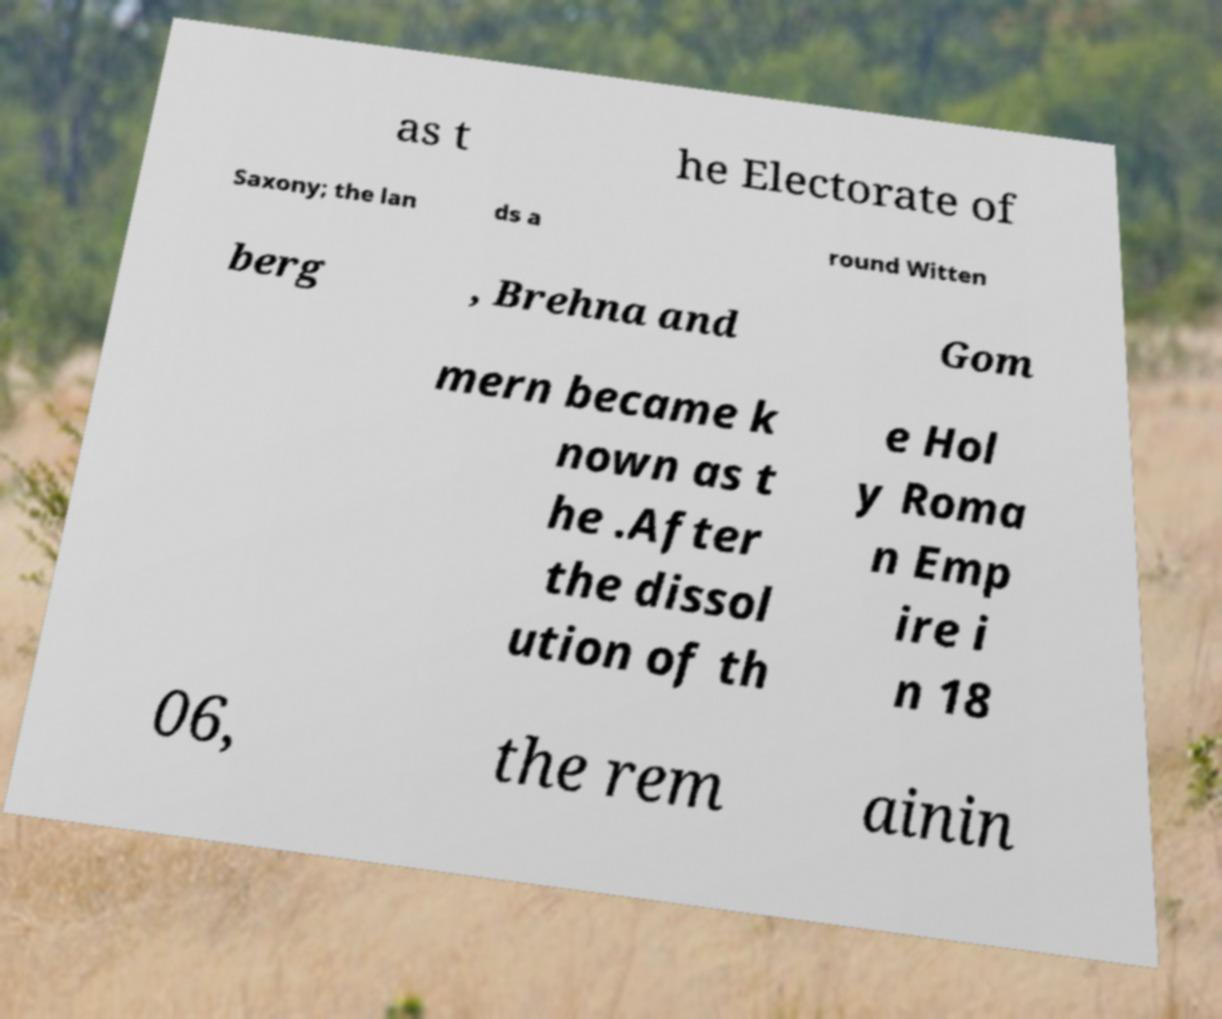What messages or text are displayed in this image? I need them in a readable, typed format. as t he Electorate of Saxony; the lan ds a round Witten berg , Brehna and Gom mern became k nown as t he .After the dissol ution of th e Hol y Roma n Emp ire i n 18 06, the rem ainin 